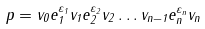Convert formula to latex. <formula><loc_0><loc_0><loc_500><loc_500>p = v _ { 0 } e _ { 1 } ^ { \varepsilon _ { 1 } } v _ { 1 } e _ { 2 } ^ { \varepsilon _ { 2 } } v _ { 2 } \dots v _ { n - 1 } e _ { n } ^ { \varepsilon _ { n } } v _ { n }</formula> 